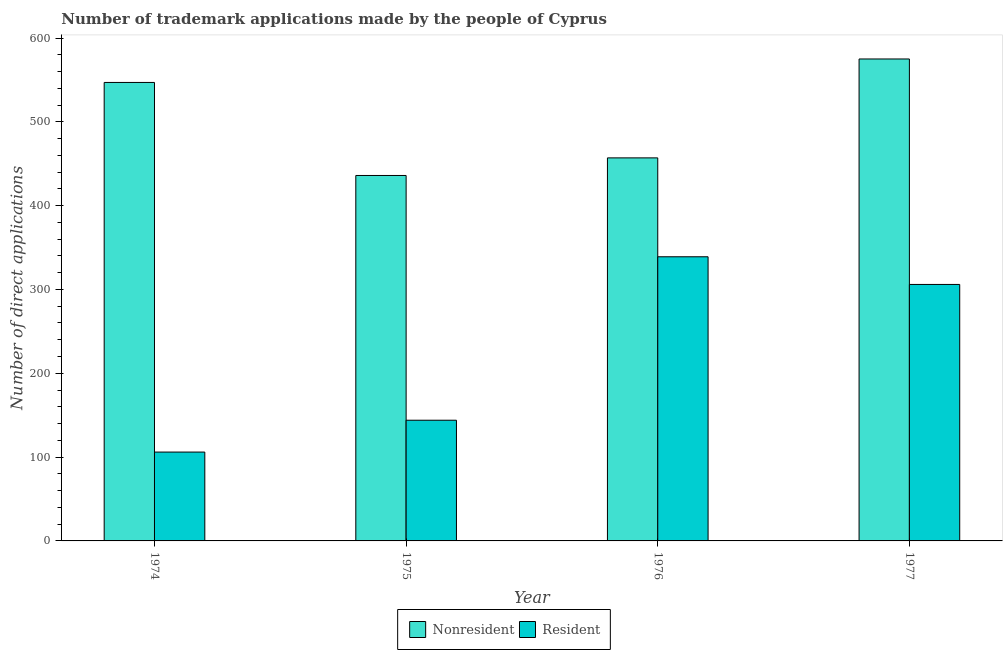Are the number of bars per tick equal to the number of legend labels?
Offer a very short reply. Yes. How many bars are there on the 4th tick from the right?
Your response must be concise. 2. What is the number of trademark applications made by residents in 1974?
Offer a terse response. 106. Across all years, what is the maximum number of trademark applications made by non residents?
Offer a very short reply. 575. Across all years, what is the minimum number of trademark applications made by non residents?
Your response must be concise. 436. In which year was the number of trademark applications made by residents maximum?
Provide a short and direct response. 1976. In which year was the number of trademark applications made by residents minimum?
Your answer should be compact. 1974. What is the total number of trademark applications made by residents in the graph?
Your answer should be very brief. 895. What is the difference between the number of trademark applications made by non residents in 1974 and that in 1975?
Make the answer very short. 111. What is the difference between the number of trademark applications made by non residents in 1976 and the number of trademark applications made by residents in 1975?
Your response must be concise. 21. What is the average number of trademark applications made by residents per year?
Give a very brief answer. 223.75. What is the ratio of the number of trademark applications made by residents in 1974 to that in 1976?
Offer a terse response. 0.31. Is the number of trademark applications made by residents in 1975 less than that in 1977?
Ensure brevity in your answer.  Yes. What is the difference between the highest and the lowest number of trademark applications made by residents?
Give a very brief answer. 233. Is the sum of the number of trademark applications made by non residents in 1974 and 1976 greater than the maximum number of trademark applications made by residents across all years?
Ensure brevity in your answer.  Yes. What does the 2nd bar from the left in 1974 represents?
Provide a short and direct response. Resident. What does the 1st bar from the right in 1975 represents?
Your answer should be compact. Resident. How many bars are there?
Keep it short and to the point. 8. Are the values on the major ticks of Y-axis written in scientific E-notation?
Offer a terse response. No. What is the title of the graph?
Keep it short and to the point. Number of trademark applications made by the people of Cyprus. What is the label or title of the Y-axis?
Ensure brevity in your answer.  Number of direct applications. What is the Number of direct applications of Nonresident in 1974?
Your response must be concise. 547. What is the Number of direct applications of Resident in 1974?
Provide a short and direct response. 106. What is the Number of direct applications of Nonresident in 1975?
Ensure brevity in your answer.  436. What is the Number of direct applications of Resident in 1975?
Your answer should be very brief. 144. What is the Number of direct applications of Nonresident in 1976?
Ensure brevity in your answer.  457. What is the Number of direct applications of Resident in 1976?
Your answer should be very brief. 339. What is the Number of direct applications in Nonresident in 1977?
Provide a short and direct response. 575. What is the Number of direct applications of Resident in 1977?
Give a very brief answer. 306. Across all years, what is the maximum Number of direct applications in Nonresident?
Offer a terse response. 575. Across all years, what is the maximum Number of direct applications in Resident?
Offer a terse response. 339. Across all years, what is the minimum Number of direct applications of Nonresident?
Provide a short and direct response. 436. Across all years, what is the minimum Number of direct applications of Resident?
Provide a short and direct response. 106. What is the total Number of direct applications in Nonresident in the graph?
Your answer should be very brief. 2015. What is the total Number of direct applications of Resident in the graph?
Keep it short and to the point. 895. What is the difference between the Number of direct applications in Nonresident in 1974 and that in 1975?
Keep it short and to the point. 111. What is the difference between the Number of direct applications in Resident in 1974 and that in 1975?
Your answer should be compact. -38. What is the difference between the Number of direct applications of Resident in 1974 and that in 1976?
Ensure brevity in your answer.  -233. What is the difference between the Number of direct applications of Nonresident in 1974 and that in 1977?
Ensure brevity in your answer.  -28. What is the difference between the Number of direct applications of Resident in 1974 and that in 1977?
Give a very brief answer. -200. What is the difference between the Number of direct applications in Nonresident in 1975 and that in 1976?
Give a very brief answer. -21. What is the difference between the Number of direct applications in Resident in 1975 and that in 1976?
Provide a succinct answer. -195. What is the difference between the Number of direct applications in Nonresident in 1975 and that in 1977?
Provide a succinct answer. -139. What is the difference between the Number of direct applications in Resident in 1975 and that in 1977?
Offer a terse response. -162. What is the difference between the Number of direct applications in Nonresident in 1976 and that in 1977?
Offer a very short reply. -118. What is the difference between the Number of direct applications of Resident in 1976 and that in 1977?
Give a very brief answer. 33. What is the difference between the Number of direct applications of Nonresident in 1974 and the Number of direct applications of Resident in 1975?
Provide a succinct answer. 403. What is the difference between the Number of direct applications in Nonresident in 1974 and the Number of direct applications in Resident in 1976?
Provide a short and direct response. 208. What is the difference between the Number of direct applications in Nonresident in 1974 and the Number of direct applications in Resident in 1977?
Make the answer very short. 241. What is the difference between the Number of direct applications of Nonresident in 1975 and the Number of direct applications of Resident in 1976?
Make the answer very short. 97. What is the difference between the Number of direct applications in Nonresident in 1975 and the Number of direct applications in Resident in 1977?
Offer a very short reply. 130. What is the difference between the Number of direct applications of Nonresident in 1976 and the Number of direct applications of Resident in 1977?
Offer a very short reply. 151. What is the average Number of direct applications of Nonresident per year?
Your answer should be compact. 503.75. What is the average Number of direct applications in Resident per year?
Offer a terse response. 223.75. In the year 1974, what is the difference between the Number of direct applications in Nonresident and Number of direct applications in Resident?
Give a very brief answer. 441. In the year 1975, what is the difference between the Number of direct applications in Nonresident and Number of direct applications in Resident?
Your answer should be very brief. 292. In the year 1976, what is the difference between the Number of direct applications in Nonresident and Number of direct applications in Resident?
Offer a terse response. 118. In the year 1977, what is the difference between the Number of direct applications in Nonresident and Number of direct applications in Resident?
Your answer should be very brief. 269. What is the ratio of the Number of direct applications in Nonresident in 1974 to that in 1975?
Offer a terse response. 1.25. What is the ratio of the Number of direct applications in Resident in 1974 to that in 1975?
Offer a very short reply. 0.74. What is the ratio of the Number of direct applications of Nonresident in 1974 to that in 1976?
Provide a succinct answer. 1.2. What is the ratio of the Number of direct applications in Resident in 1974 to that in 1976?
Offer a very short reply. 0.31. What is the ratio of the Number of direct applications in Nonresident in 1974 to that in 1977?
Your response must be concise. 0.95. What is the ratio of the Number of direct applications in Resident in 1974 to that in 1977?
Give a very brief answer. 0.35. What is the ratio of the Number of direct applications in Nonresident in 1975 to that in 1976?
Your answer should be very brief. 0.95. What is the ratio of the Number of direct applications of Resident in 1975 to that in 1976?
Offer a very short reply. 0.42. What is the ratio of the Number of direct applications in Nonresident in 1975 to that in 1977?
Give a very brief answer. 0.76. What is the ratio of the Number of direct applications in Resident in 1975 to that in 1977?
Provide a short and direct response. 0.47. What is the ratio of the Number of direct applications of Nonresident in 1976 to that in 1977?
Make the answer very short. 0.79. What is the ratio of the Number of direct applications in Resident in 1976 to that in 1977?
Your answer should be compact. 1.11. What is the difference between the highest and the second highest Number of direct applications in Nonresident?
Give a very brief answer. 28. What is the difference between the highest and the lowest Number of direct applications in Nonresident?
Keep it short and to the point. 139. What is the difference between the highest and the lowest Number of direct applications of Resident?
Offer a very short reply. 233. 